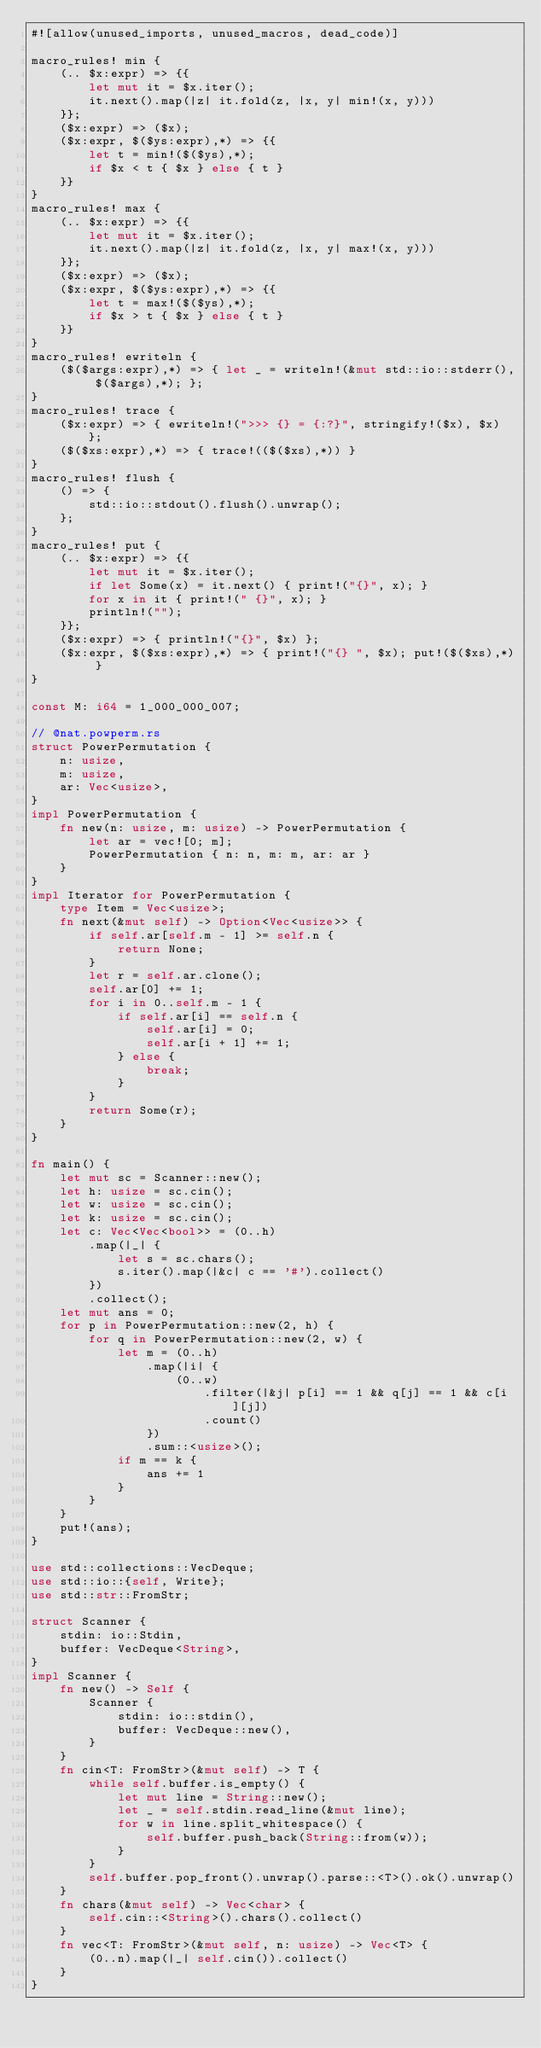Convert code to text. <code><loc_0><loc_0><loc_500><loc_500><_Rust_>#![allow(unused_imports, unused_macros, dead_code)]

macro_rules! min {
    (.. $x:expr) => {{
        let mut it = $x.iter();
        it.next().map(|z| it.fold(z, |x, y| min!(x, y)))
    }};
    ($x:expr) => ($x);
    ($x:expr, $($ys:expr),*) => {{
        let t = min!($($ys),*);
        if $x < t { $x } else { t }
    }}
}
macro_rules! max {
    (.. $x:expr) => {{
        let mut it = $x.iter();
        it.next().map(|z| it.fold(z, |x, y| max!(x, y)))
    }};
    ($x:expr) => ($x);
    ($x:expr, $($ys:expr),*) => {{
        let t = max!($($ys),*);
        if $x > t { $x } else { t }
    }}
}
macro_rules! ewriteln {
    ($($args:expr),*) => { let _ = writeln!(&mut std::io::stderr(), $($args),*); };
}
macro_rules! trace {
    ($x:expr) => { ewriteln!(">>> {} = {:?}", stringify!($x), $x) };
    ($($xs:expr),*) => { trace!(($($xs),*)) }
}
macro_rules! flush {
    () => {
        std::io::stdout().flush().unwrap();
    };
}
macro_rules! put {
    (.. $x:expr) => {{
        let mut it = $x.iter();
        if let Some(x) = it.next() { print!("{}", x); }
        for x in it { print!(" {}", x); }
        println!("");
    }};
    ($x:expr) => { println!("{}", $x) };
    ($x:expr, $($xs:expr),*) => { print!("{} ", $x); put!($($xs),*) }
}

const M: i64 = 1_000_000_007;

// @nat.powperm.rs
struct PowerPermutation {
    n: usize,
    m: usize,
    ar: Vec<usize>,
}
impl PowerPermutation {
    fn new(n: usize, m: usize) -> PowerPermutation {
        let ar = vec![0; m];
        PowerPermutation { n: n, m: m, ar: ar }
    }
}
impl Iterator for PowerPermutation {
    type Item = Vec<usize>;
    fn next(&mut self) -> Option<Vec<usize>> {
        if self.ar[self.m - 1] >= self.n {
            return None;
        }
        let r = self.ar.clone();
        self.ar[0] += 1;
        for i in 0..self.m - 1 {
            if self.ar[i] == self.n {
                self.ar[i] = 0;
                self.ar[i + 1] += 1;
            } else {
                break;
            }
        }
        return Some(r);
    }
}

fn main() {
    let mut sc = Scanner::new();
    let h: usize = sc.cin();
    let w: usize = sc.cin();
    let k: usize = sc.cin();
    let c: Vec<Vec<bool>> = (0..h)
        .map(|_| {
            let s = sc.chars();
            s.iter().map(|&c| c == '#').collect()
        })
        .collect();
    let mut ans = 0;
    for p in PowerPermutation::new(2, h) {
        for q in PowerPermutation::new(2, w) {
            let m = (0..h)
                .map(|i| {
                    (0..w)
                        .filter(|&j| p[i] == 1 && q[j] == 1 && c[i][j])
                        .count()
                })
                .sum::<usize>();
            if m == k {
                ans += 1
            }
        }
    }
    put!(ans);
}

use std::collections::VecDeque;
use std::io::{self, Write};
use std::str::FromStr;

struct Scanner {
    stdin: io::Stdin,
    buffer: VecDeque<String>,
}
impl Scanner {
    fn new() -> Self {
        Scanner {
            stdin: io::stdin(),
            buffer: VecDeque::new(),
        }
    }
    fn cin<T: FromStr>(&mut self) -> T {
        while self.buffer.is_empty() {
            let mut line = String::new();
            let _ = self.stdin.read_line(&mut line);
            for w in line.split_whitespace() {
                self.buffer.push_back(String::from(w));
            }
        }
        self.buffer.pop_front().unwrap().parse::<T>().ok().unwrap()
    }
    fn chars(&mut self) -> Vec<char> {
        self.cin::<String>().chars().collect()
    }
    fn vec<T: FromStr>(&mut self, n: usize) -> Vec<T> {
        (0..n).map(|_| self.cin()).collect()
    }
}
</code> 